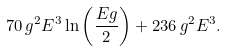<formula> <loc_0><loc_0><loc_500><loc_500>7 0 \, g ^ { 2 } E ^ { 3 } \ln \left ( \frac { E g } { 2 } \right ) + 2 3 6 \, g ^ { 2 } E ^ { 3 } .</formula> 